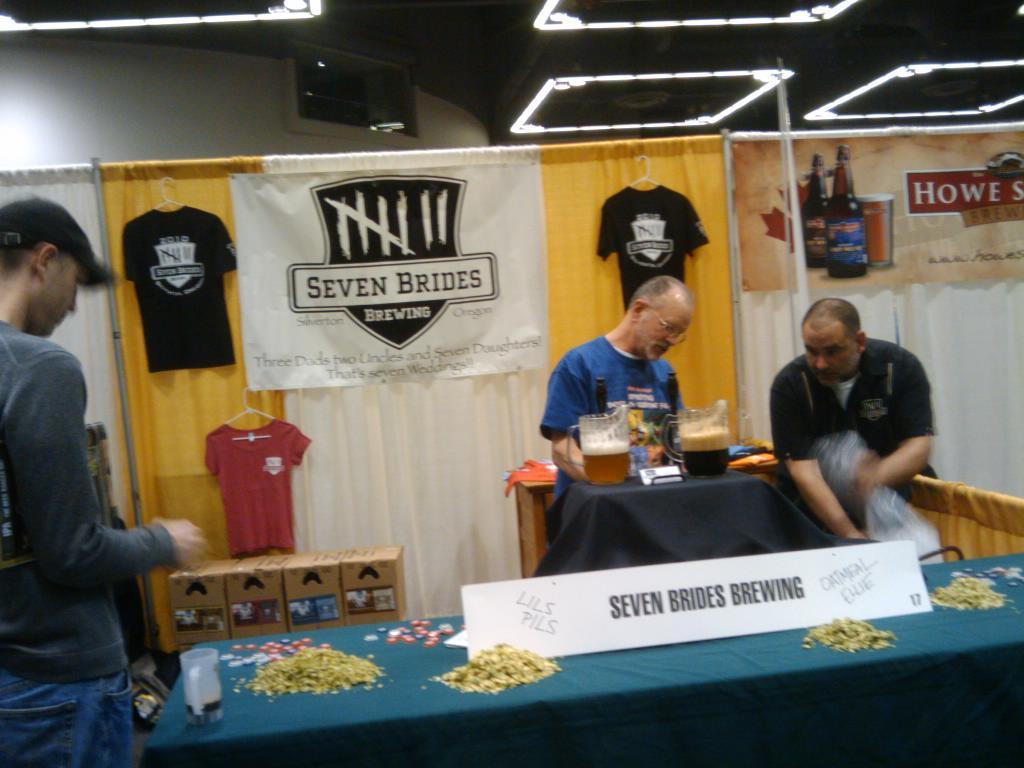What is hanging in the image? There is a banner in the image. How many people are present in the image? There are three people standing in the image. What is on the table in the image? There is another banner, mugs, and papers on the table. What might the people be using the mugs for? The mugs could be used for holding drinks or other beverages. What type of instrument is being played by the people in the image? There is no instrument present in the image; the people are simply standing. What type of prison is depicted in the image? There is no prison present in the image. 